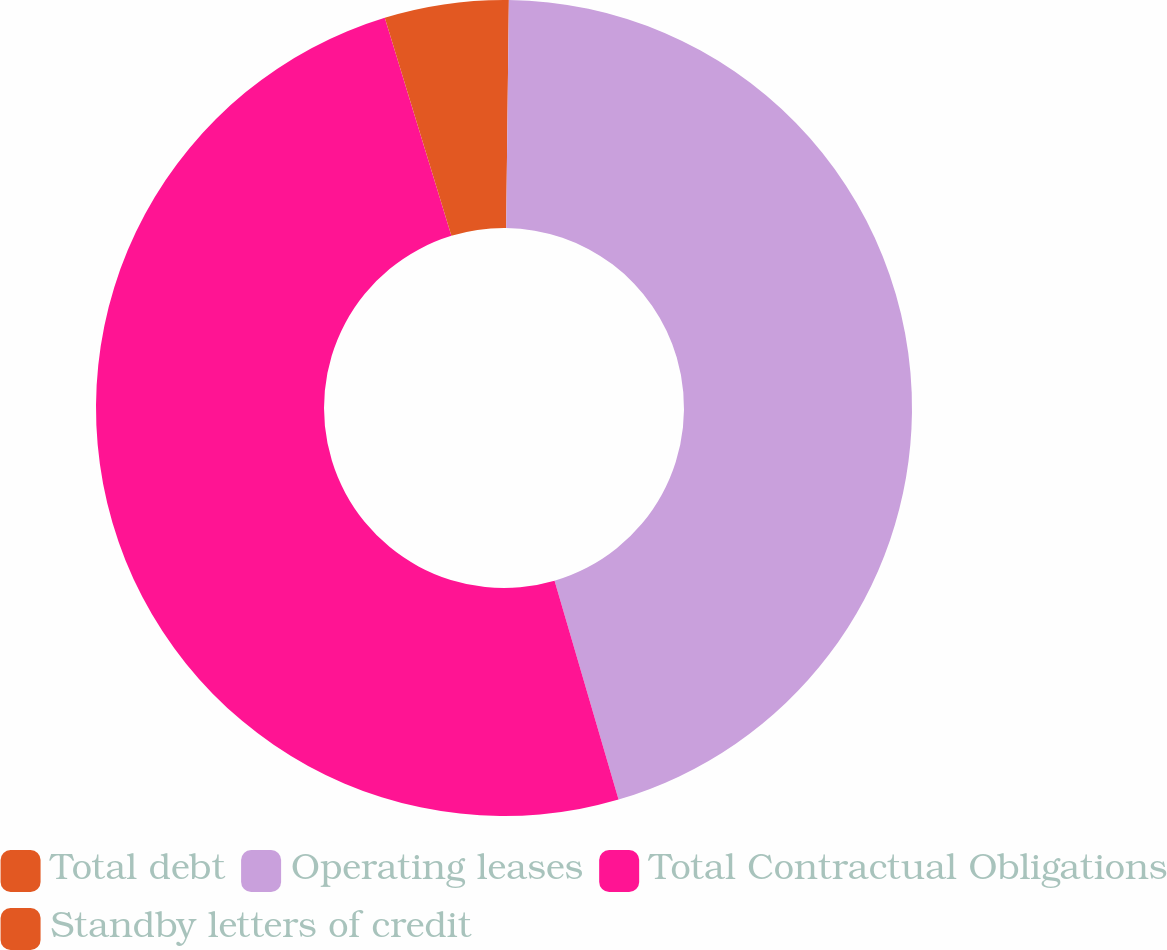Convert chart. <chart><loc_0><loc_0><loc_500><loc_500><pie_chart><fcel>Total debt<fcel>Operating leases<fcel>Total Contractual Obligations<fcel>Standby letters of credit<nl><fcel>0.19%<fcel>45.28%<fcel>49.81%<fcel>4.72%<nl></chart> 